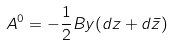Convert formula to latex. <formula><loc_0><loc_0><loc_500><loc_500>A ^ { 0 } = - \frac { 1 } { 2 } B y ( d z + d \bar { z } )</formula> 